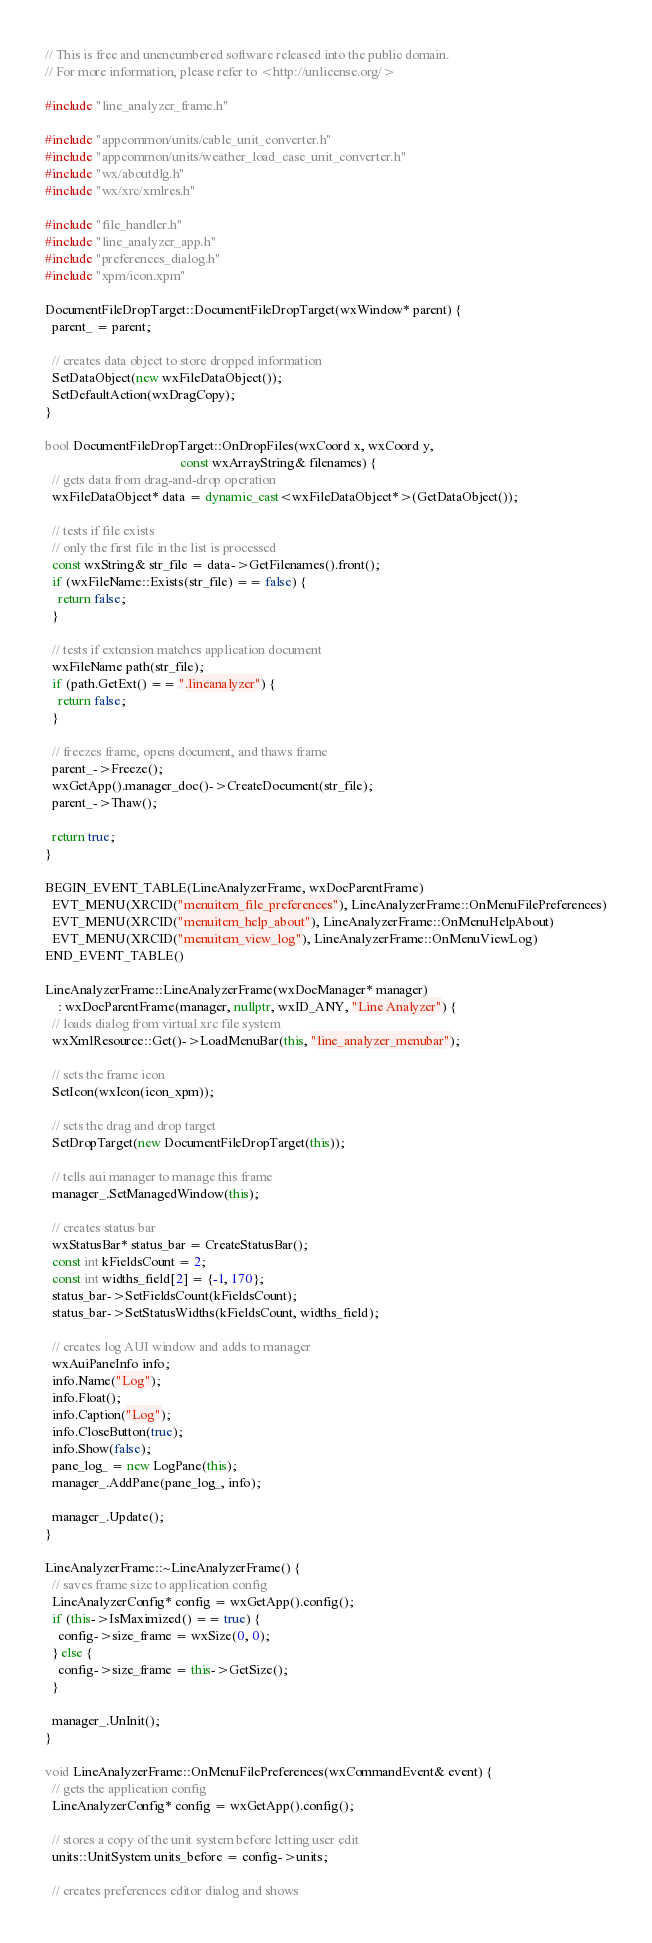<code> <loc_0><loc_0><loc_500><loc_500><_C++_>// This is free and unencumbered software released into the public domain.
// For more information, please refer to <http://unlicense.org/>

#include "line_analyzer_frame.h"

#include "appcommon/units/cable_unit_converter.h"
#include "appcommon/units/weather_load_case_unit_converter.h"
#include "wx/aboutdlg.h"
#include "wx/xrc/xmlres.h"

#include "file_handler.h"
#include "line_analyzer_app.h"
#include "preferences_dialog.h"
#include "xpm/icon.xpm"

DocumentFileDropTarget::DocumentFileDropTarget(wxWindow* parent) {
  parent_ = parent;

  // creates data object to store dropped information
  SetDataObject(new wxFileDataObject());
  SetDefaultAction(wxDragCopy);
}

bool DocumentFileDropTarget::OnDropFiles(wxCoord x, wxCoord y,
                                         const wxArrayString& filenames) {
  // gets data from drag-and-drop operation
  wxFileDataObject* data = dynamic_cast<wxFileDataObject*>(GetDataObject());

  // tests if file exists
  // only the first file in the list is processed
  const wxString& str_file = data->GetFilenames().front();
  if (wxFileName::Exists(str_file) == false) {
    return false;
  }

  // tests if extension matches application document
  wxFileName path(str_file);
  if (path.GetExt() == ".lineanalyzer") {
    return false;
  }

  // freezes frame, opens document, and thaws frame
  parent_->Freeze();
  wxGetApp().manager_doc()->CreateDocument(str_file);
  parent_->Thaw();

  return true;
}

BEGIN_EVENT_TABLE(LineAnalyzerFrame, wxDocParentFrame)
  EVT_MENU(XRCID("menuitem_file_preferences"), LineAnalyzerFrame::OnMenuFilePreferences)
  EVT_MENU(XRCID("menuitem_help_about"), LineAnalyzerFrame::OnMenuHelpAbout)
  EVT_MENU(XRCID("menuitem_view_log"), LineAnalyzerFrame::OnMenuViewLog)
END_EVENT_TABLE()

LineAnalyzerFrame::LineAnalyzerFrame(wxDocManager* manager)
    : wxDocParentFrame(manager, nullptr, wxID_ANY, "Line Analyzer") {
  // loads dialog from virtual xrc file system
  wxXmlResource::Get()->LoadMenuBar(this, "line_analyzer_menubar");

  // sets the frame icon
  SetIcon(wxIcon(icon_xpm));

  // sets the drag and drop target
  SetDropTarget(new DocumentFileDropTarget(this));

  // tells aui manager to manage this frame
  manager_.SetManagedWindow(this);

  // creates status bar
  wxStatusBar* status_bar = CreateStatusBar();
  const int kFieldsCount = 2;
  const int widths_field[2] = {-1, 170};
  status_bar->SetFieldsCount(kFieldsCount);
  status_bar->SetStatusWidths(kFieldsCount, widths_field);

  // creates log AUI window and adds to manager
  wxAuiPaneInfo info;
  info.Name("Log");
  info.Float();
  info.Caption("Log");
  info.CloseButton(true);
  info.Show(false);
  pane_log_ = new LogPane(this);
  manager_.AddPane(pane_log_, info);

  manager_.Update();
}

LineAnalyzerFrame::~LineAnalyzerFrame() {
  // saves frame size to application config
  LineAnalyzerConfig* config = wxGetApp().config();
  if (this->IsMaximized() == true) {
    config->size_frame = wxSize(0, 0);
  } else {
    config->size_frame = this->GetSize();
  }

  manager_.UnInit();
}

void LineAnalyzerFrame::OnMenuFilePreferences(wxCommandEvent& event) {
  // gets the application config
  LineAnalyzerConfig* config = wxGetApp().config();

  // stores a copy of the unit system before letting user edit
  units::UnitSystem units_before = config->units;

  // creates preferences editor dialog and shows</code> 